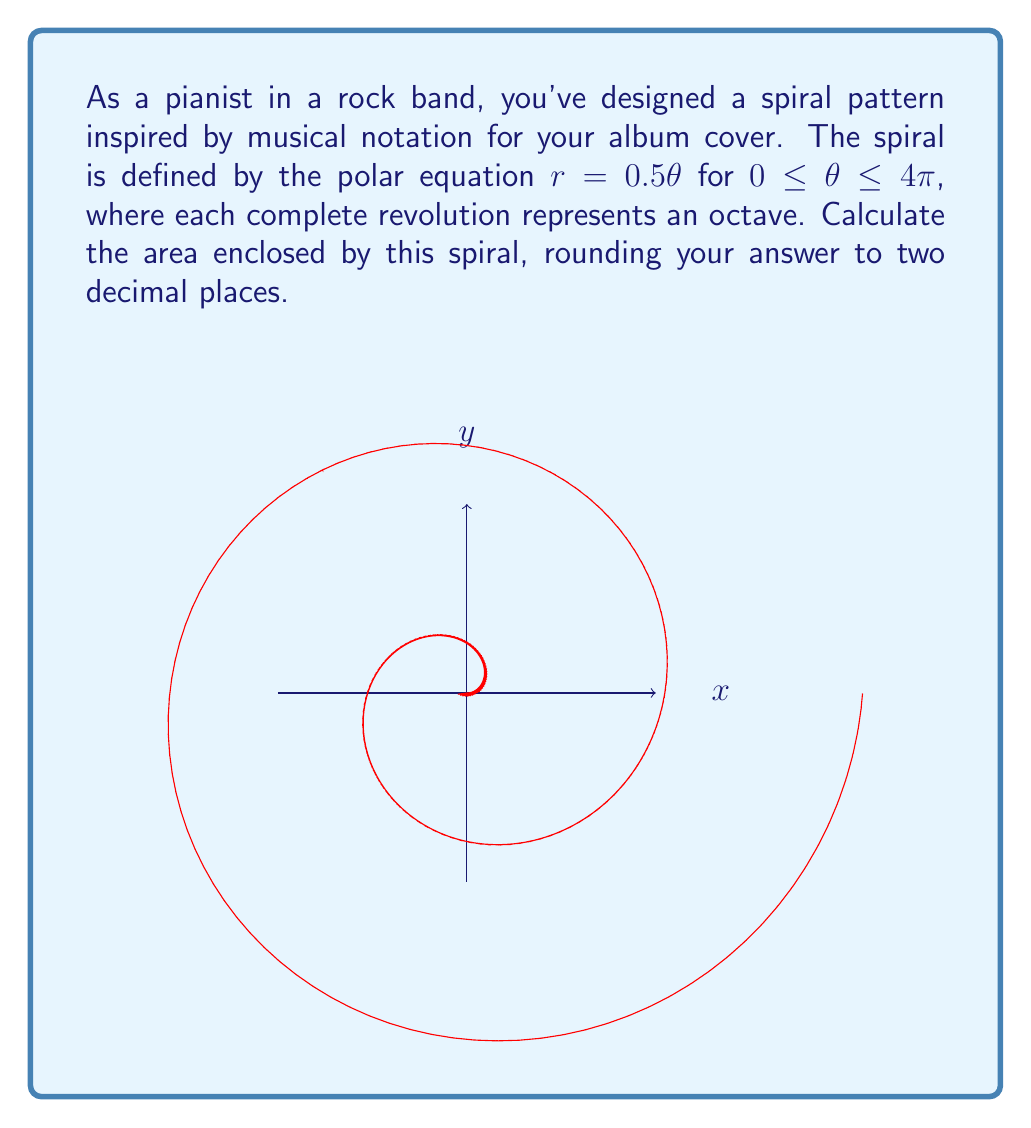What is the answer to this math problem? Let's approach this step-by-step:

1) The area of a polar curve is given by the formula:

   $$A = \frac{1}{2} \int_a^b r^2(\theta) d\theta$$

2) In this case, $r(\theta) = 0.5\theta$, $a = 0$, and $b = 4\pi$

3) Substituting these into the formula:

   $$A = \frac{1}{2} \int_0^{4\pi} (0.5\theta)^2 d\theta$$

4) Simplify the integrand:

   $$A = \frac{1}{2} \int_0^{4\pi} 0.25\theta^2 d\theta$$

5) Integrate:

   $$A = \frac{1}{2} \cdot 0.25 \cdot [\frac{1}{3}\theta^3]_0^{4\pi}$$

6) Evaluate the integral:

   $$A = \frac{1}{8} \cdot [\frac{1}{3}(4\pi)^3 - 0]$$

7) Simplify:

   $$A = \frac{1}{8} \cdot \frac{1}{3} \cdot 64\pi^3 = \frac{8\pi^3}{3}$$

8) Calculate and round to two decimal places:

   $$A \approx 26.32$$
Answer: $26.32$ square units 